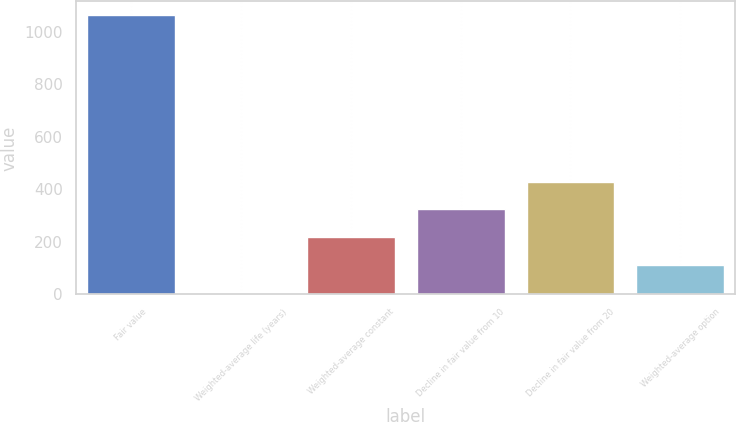<chart> <loc_0><loc_0><loc_500><loc_500><bar_chart><fcel>Fair value<fcel>Weighted-average life (years)<fcel>Weighted-average constant<fcel>Decline in fair value from 10<fcel>Decline in fair value from 20<fcel>Weighted-average option<nl><fcel>1063<fcel>6.3<fcel>217.64<fcel>323.31<fcel>428.98<fcel>111.97<nl></chart> 